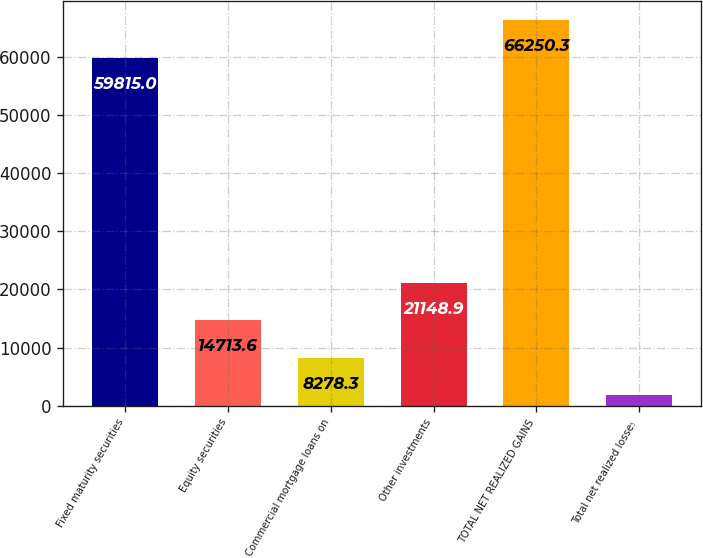Convert chart to OTSL. <chart><loc_0><loc_0><loc_500><loc_500><bar_chart><fcel>Fixed maturity securities<fcel>Equity securities<fcel>Commercial mortgage loans on<fcel>Other investments<fcel>TOTAL NET REALIZED GAINS<fcel>Total net realized losses<nl><fcel>59815<fcel>14713.6<fcel>8278.3<fcel>21148.9<fcel>66250.3<fcel>1843<nl></chart> 